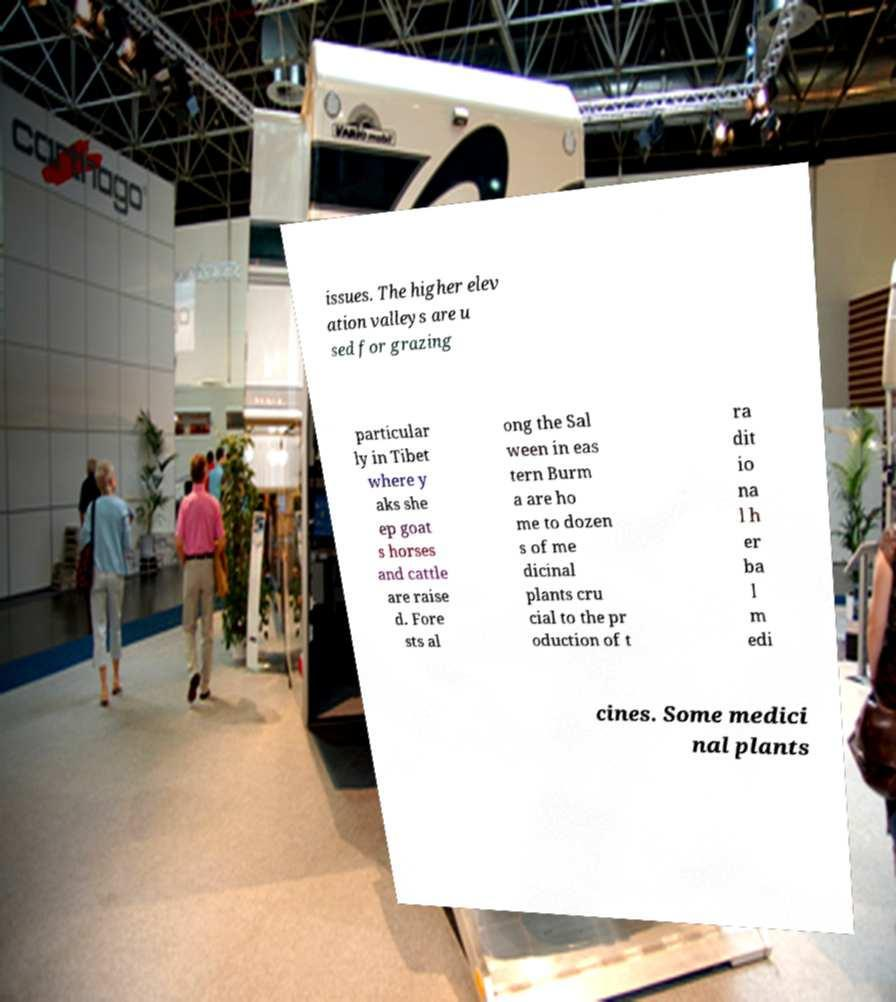Please identify and transcribe the text found in this image. issues. The higher elev ation valleys are u sed for grazing particular ly in Tibet where y aks she ep goat s horses and cattle are raise d. Fore sts al ong the Sal ween in eas tern Burm a are ho me to dozen s of me dicinal plants cru cial to the pr oduction of t ra dit io na l h er ba l m edi cines. Some medici nal plants 